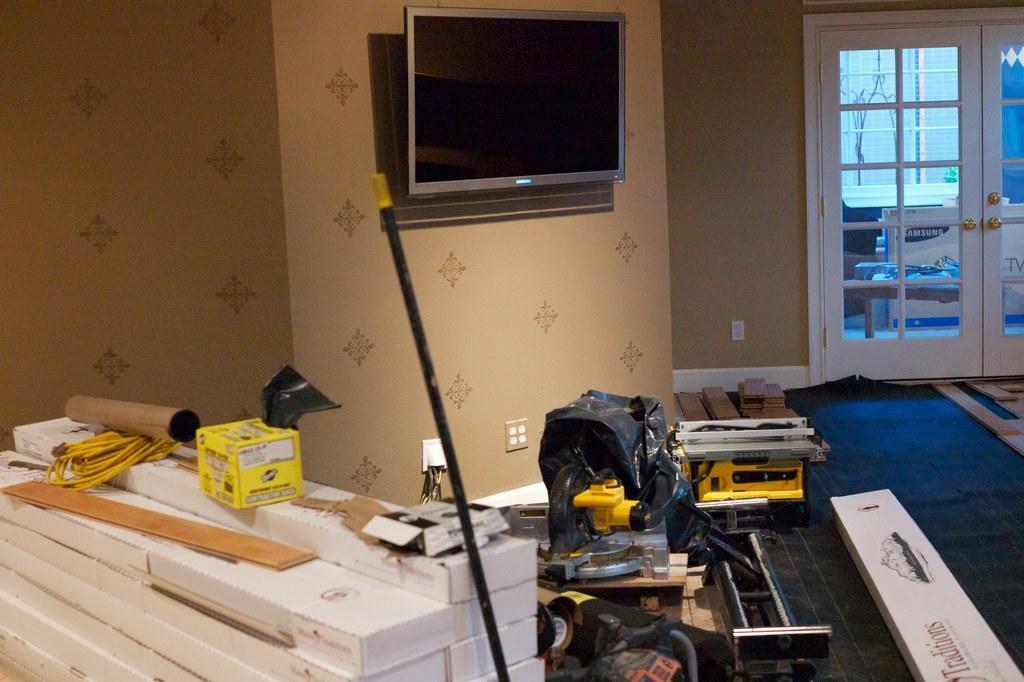Could you give a brief overview of what you see in this image? In this image I can see a wall and a screen attached to the wall in the middle , on the floor I can see some equipments kept on that, on the right side I can see a door , through door I can see some objects 